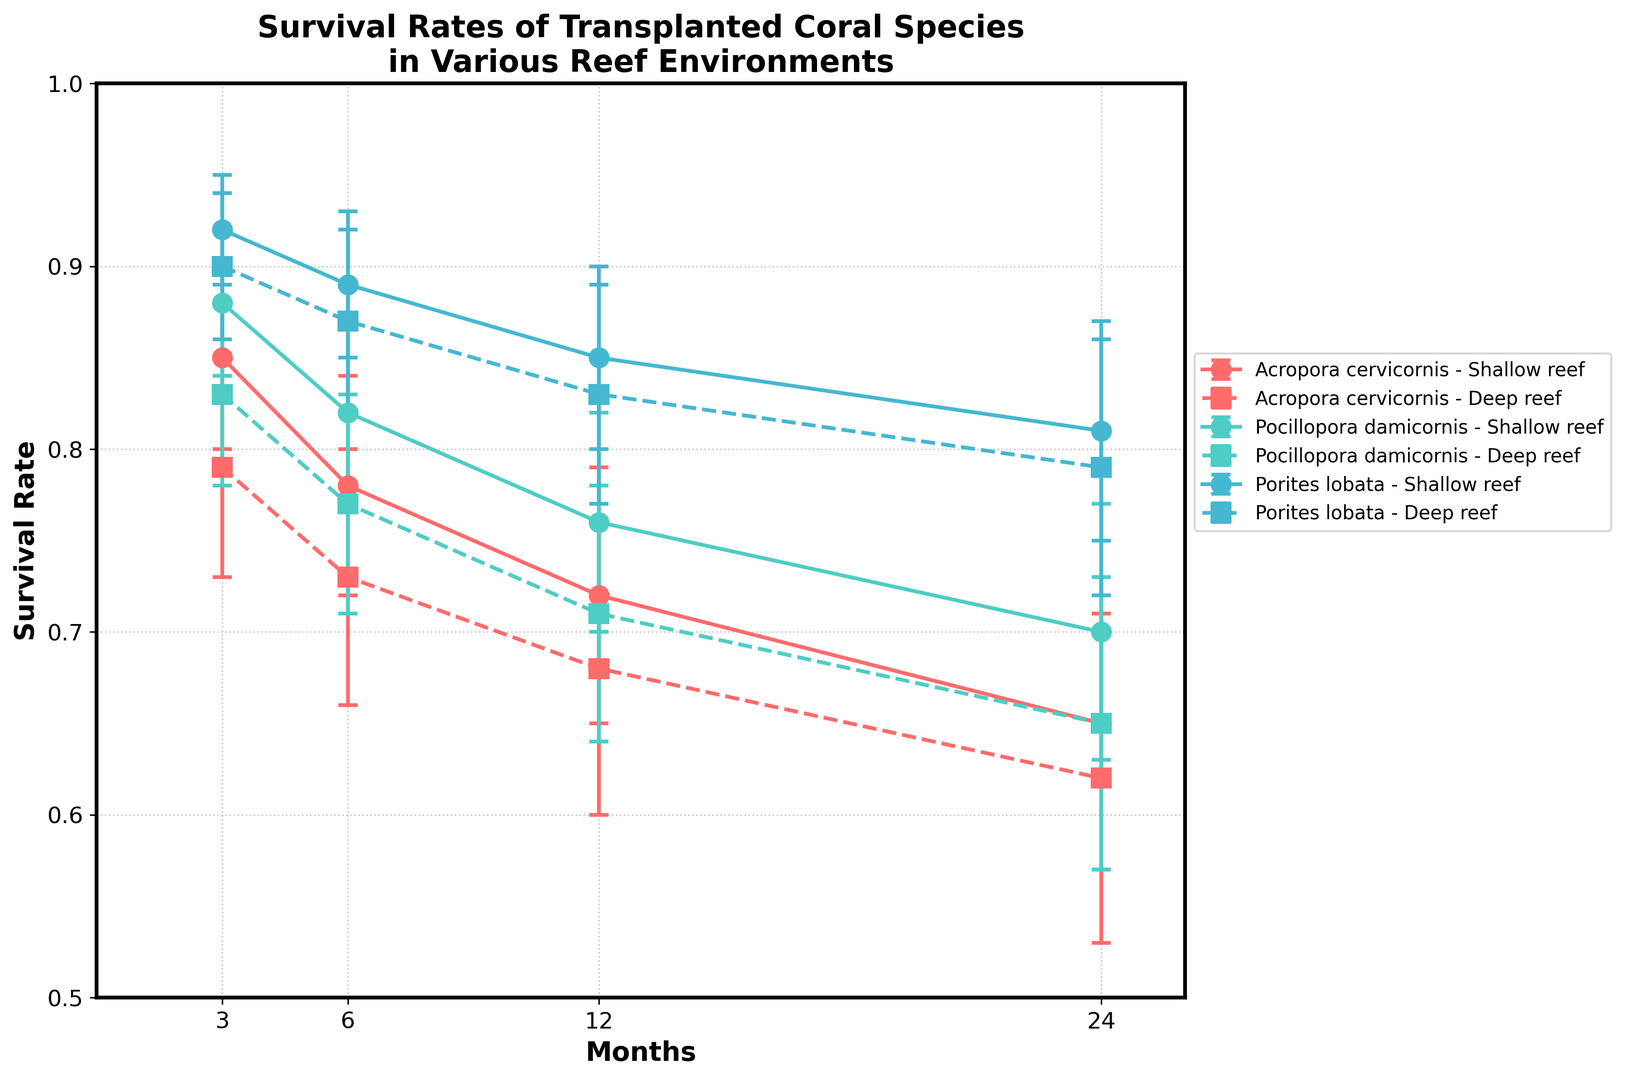What species shows the highest survival rate in shallow reefs after 12 months? The highest survival rate in shallow reefs after 12 months is observed in Porites lobata, which has a survival rate of 0.85 as indicated by the highest point amongst the species for that environment and time.
Answer: Porites lobata Does the survival rate of Pocillopora damicornis in deep reefs decrease more rapidly between 3 and 24 months compared to the survival rate of Acropora cervicornis in the same condition? To determine the rate change, we calculate the difference over time for both species. For Pocillopora damicornis in deep reefs, it decreases from 0.83 to 0.65 over 21 months, a decline of 0.18. For Acropora cervicornis in deep reefs, it decreases from 0.79 to 0.62 over 21 months, a decline of 0.17. Thus, Pocillopora damicornis shows a faster decline.
Answer: Yes Which environment, shallow reef or deep reef, generally demonstrates higher survival rates for Acropora cervicornis after 6 months? Comparing the survival rates after 6 months for Acropora cervicornis, we see that the shallow reef has a survival rate of 0.78, while the deep reef has a survival rate of 0.73. Hence, shallow reefs exhibit higher survival rates.
Answer: Shallow reef How do the error margins for Porites lobata in shallow reefs compare over 12 and 24 months? For Porites lobata in shallow reefs, the error margins are 0.05 at 12 months and 0.06 at 24 months. This indicates a slight increase in the error margin over time.
Answer: Increase On average, what is the survival rate of Porites lobata across both environments after 24 months? To find the average, combine the survival rates across both environments at 24 months: (0.81 from shallow reefs + 0.79 from deep reefs) / 2 = 0.80.
Answer: 0.80 Which species has a consistently higher survival rate in deep reefs as compared to shallow reefs? We compare the survival rates across time points for each species. Acropora cervicornis and Pocillopora damicornis generally show higher survival rates in shallow reefs, but Porites lobata has higher rates in deep reefs indicating consistency.
Answer: Porites lobata Is there any species and environment combination where the survival rate remains above 0.80 after 24 months? We look at the survival rates after 24 months for each species and environment combination. The only species with a survival rate above 0.80 is Porites lobata in both shallow reefs (0.81) and deep reefs (0.79), though deep reefs are slightly below 0.80.
Answer: Porites lobata in shallow reefs Which reef environment shows greater variability in the survival rate of Acropora cervicornis based on error margins over 24 months? By comparing the error margins over time for each environment, Acropora cervicornis in deep reefs shows higher variability (e.g., 0.09 at 24 months compared to 0.08 in shallow reefs), indicating greater variability in this environment.
Answer: Deep reef How does the survival rate trend over time for Pocillopora damicornis differ between shallow and deep reefs? Comparing the trends, Pocillopora damicornis has an initially higher rate in shallow reefs, but both environments show a decrease over time. The rate in shallow reefs decreases from 0.88 to 0.70, and in deep reefs from 0.83 to 0.65. Both show a decline, but shallow reefs maintain slightly higher rates throughout.
Answer: Shallow reefs decline slower Which coral species maintains the highest overall survival rate across both environments and all time periods? Observing the highest points among all the data, Porites lobata demonstrates the highest overall survival rates across both environments and all time periods, especially noticeable within the first 12 months.
Answer: Porites lobata 